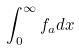<formula> <loc_0><loc_0><loc_500><loc_500>\int _ { 0 } ^ { \infty } f _ { a } d x</formula> 